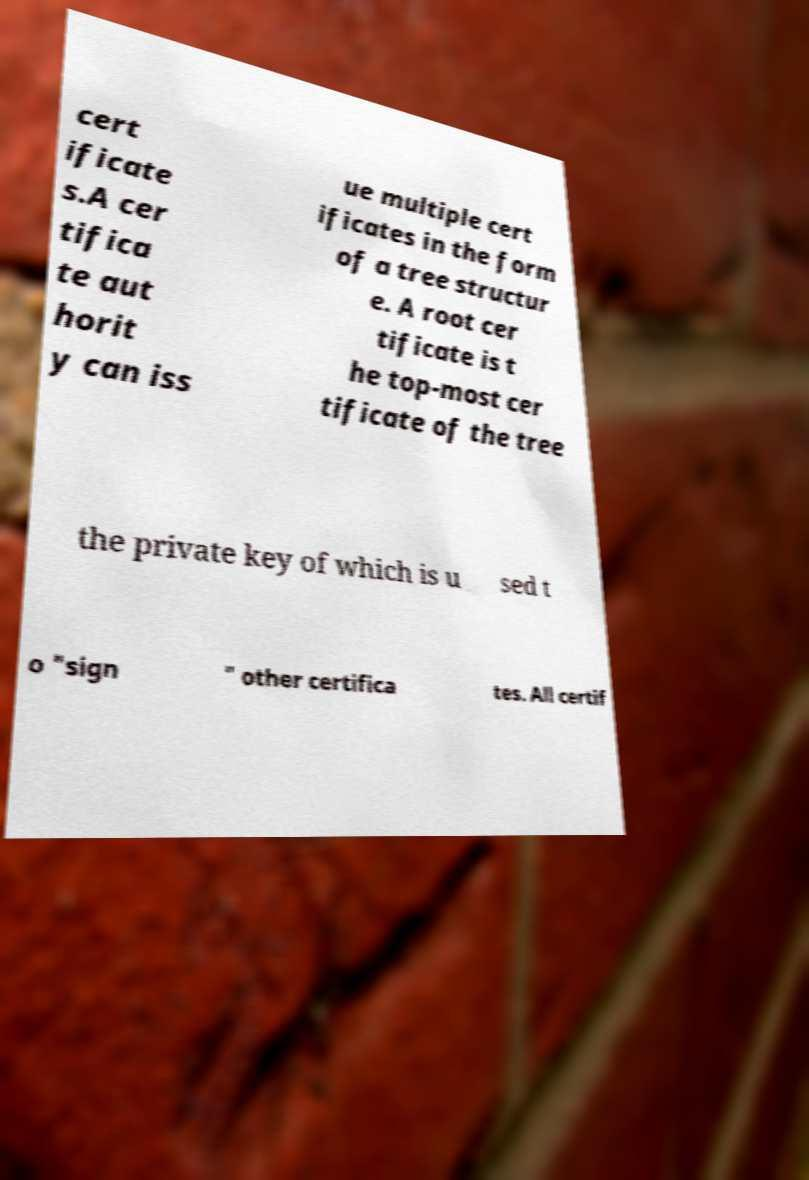Can you accurately transcribe the text from the provided image for me? cert ificate s.A cer tifica te aut horit y can iss ue multiple cert ificates in the form of a tree structur e. A root cer tificate is t he top-most cer tificate of the tree the private key of which is u sed t o "sign " other certifica tes. All certif 